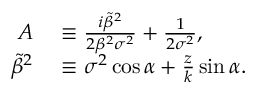Convert formula to latex. <formula><loc_0><loc_0><loc_500><loc_500>\begin{array} { r l } { A } & \equiv \frac { i \tilde { \beta } ^ { 2 } } { 2 \beta ^ { 2 } \sigma ^ { 2 } } + \frac { 1 } { 2 \sigma ^ { 2 } } , } \\ { \tilde { \beta } ^ { 2 } } & \equiv \sigma ^ { 2 } \cos { \alpha } + \frac { z } { k } \sin { \alpha } . } \end{array}</formula> 